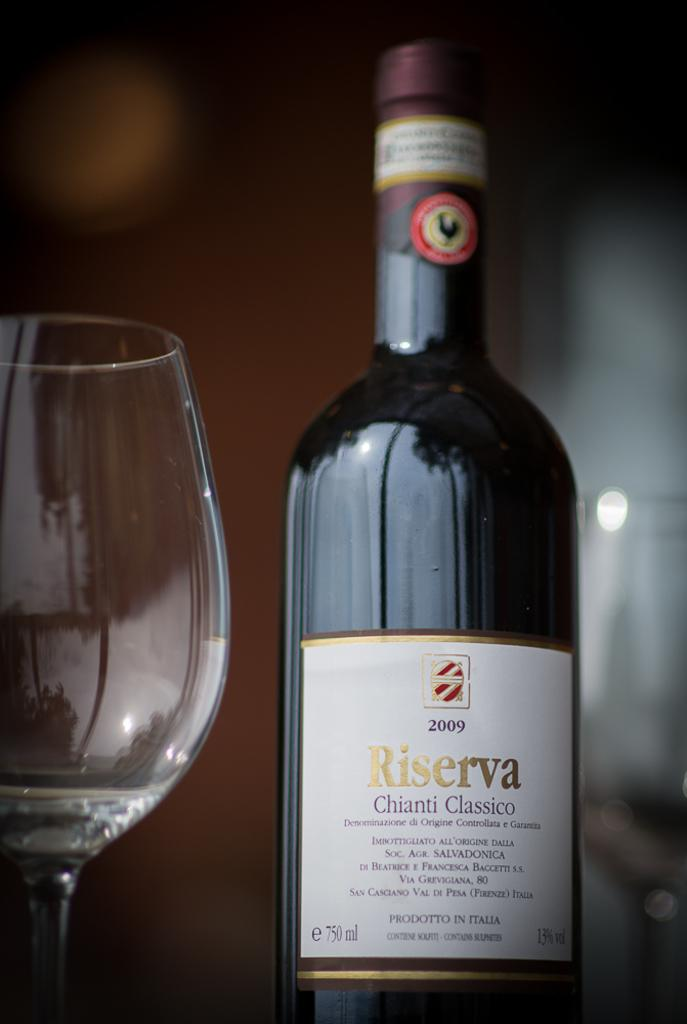<image>
Summarize the visual content of the image. A 2009 bottle of Chianti is waiting to be opened. 